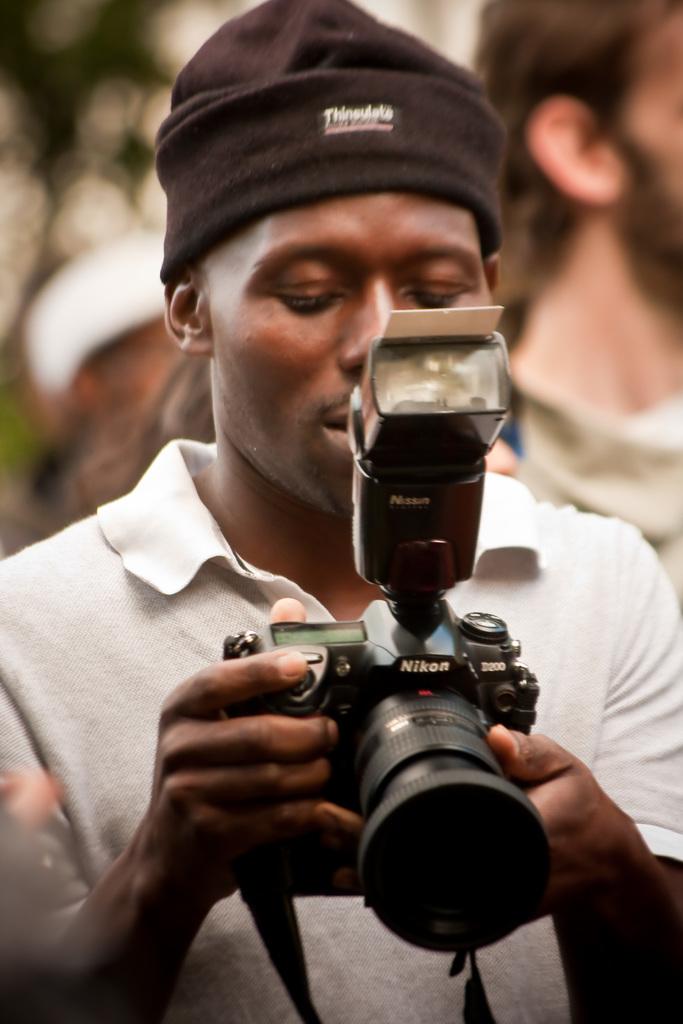What brand of camera is this?
Your answer should be compact. Nikon. Does his beanie say thinsulate on it?
Provide a succinct answer. Yes. 